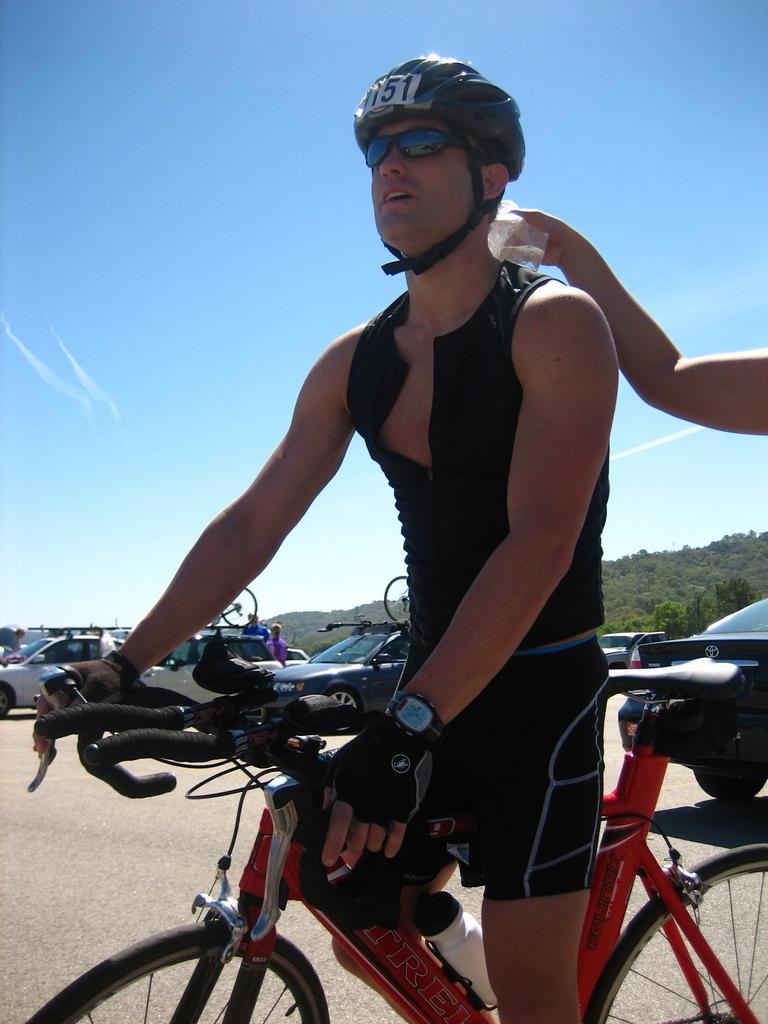Who is present in the image? There is a man in the image. What is the man holding in the image? The man is holding a bicycle. What safety gear is the man wearing in the image? The man is wearing a helmet in the image. How many women are present in the image? There are no women present in the image; it features a man holding a bicycle and wearing a helmet. What type of beetle can be seen crawling on the man's nose in the image? There is no beetle present on the man's nose in the image. 